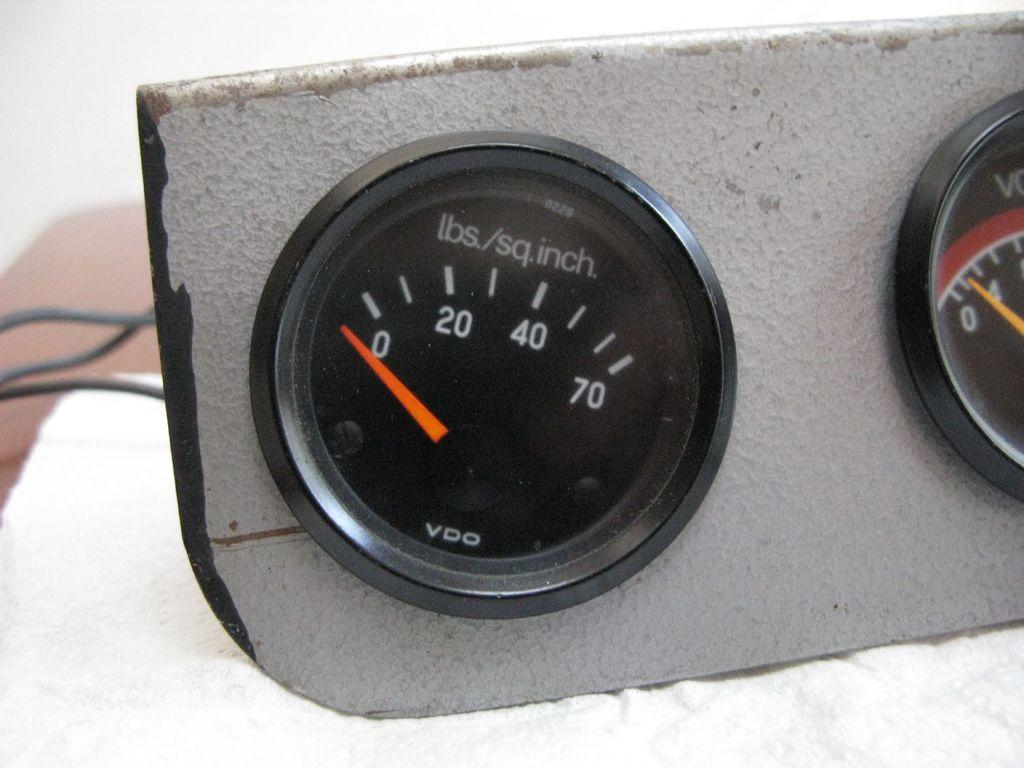What can be seen in the image related to measurement or control? There are two gauges in the image. What is located on the left side of the image? There are three wires on the left side of the image. Can you describe the background of the image? The background of the image appears blurry. What type of wrist accessory is visible on the gauges in the image? There are no wrist accessories present on the gauges in the image. What experience can be gained from observing the gauges in the image? The image does not convey any specific experience or knowledge related to the gauges. 